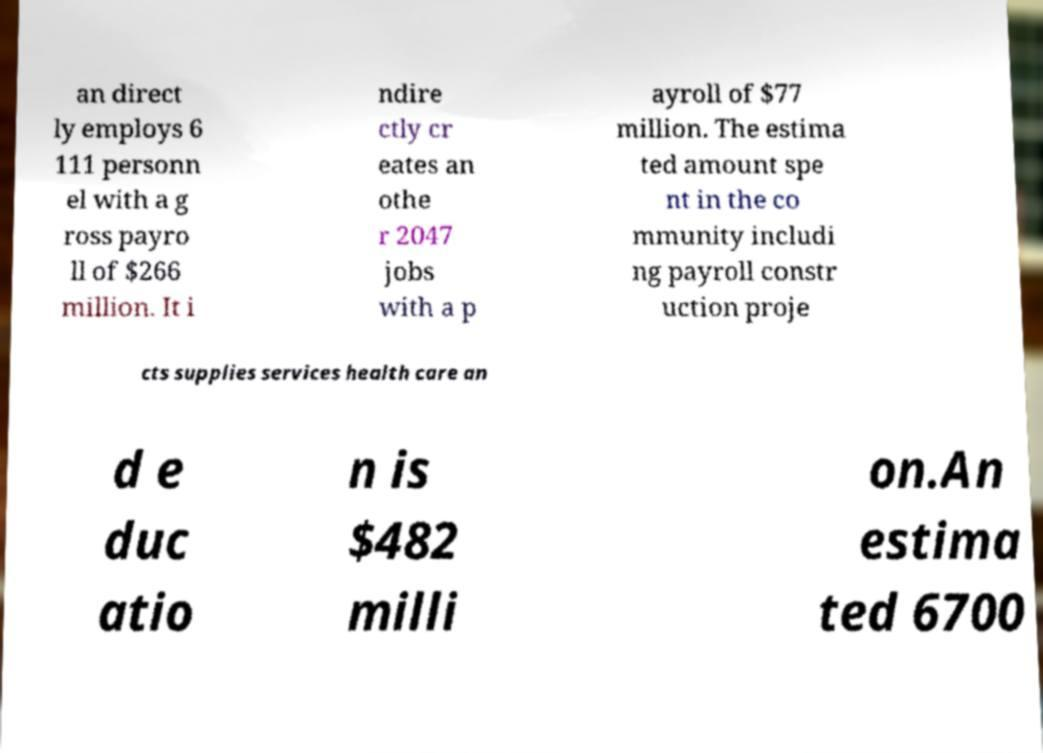For documentation purposes, I need the text within this image transcribed. Could you provide that? an direct ly employs 6 111 personn el with a g ross payro ll of $266 million. It i ndire ctly cr eates an othe r 2047 jobs with a p ayroll of $77 million. The estima ted amount spe nt in the co mmunity includi ng payroll constr uction proje cts supplies services health care an d e duc atio n is $482 milli on.An estima ted 6700 